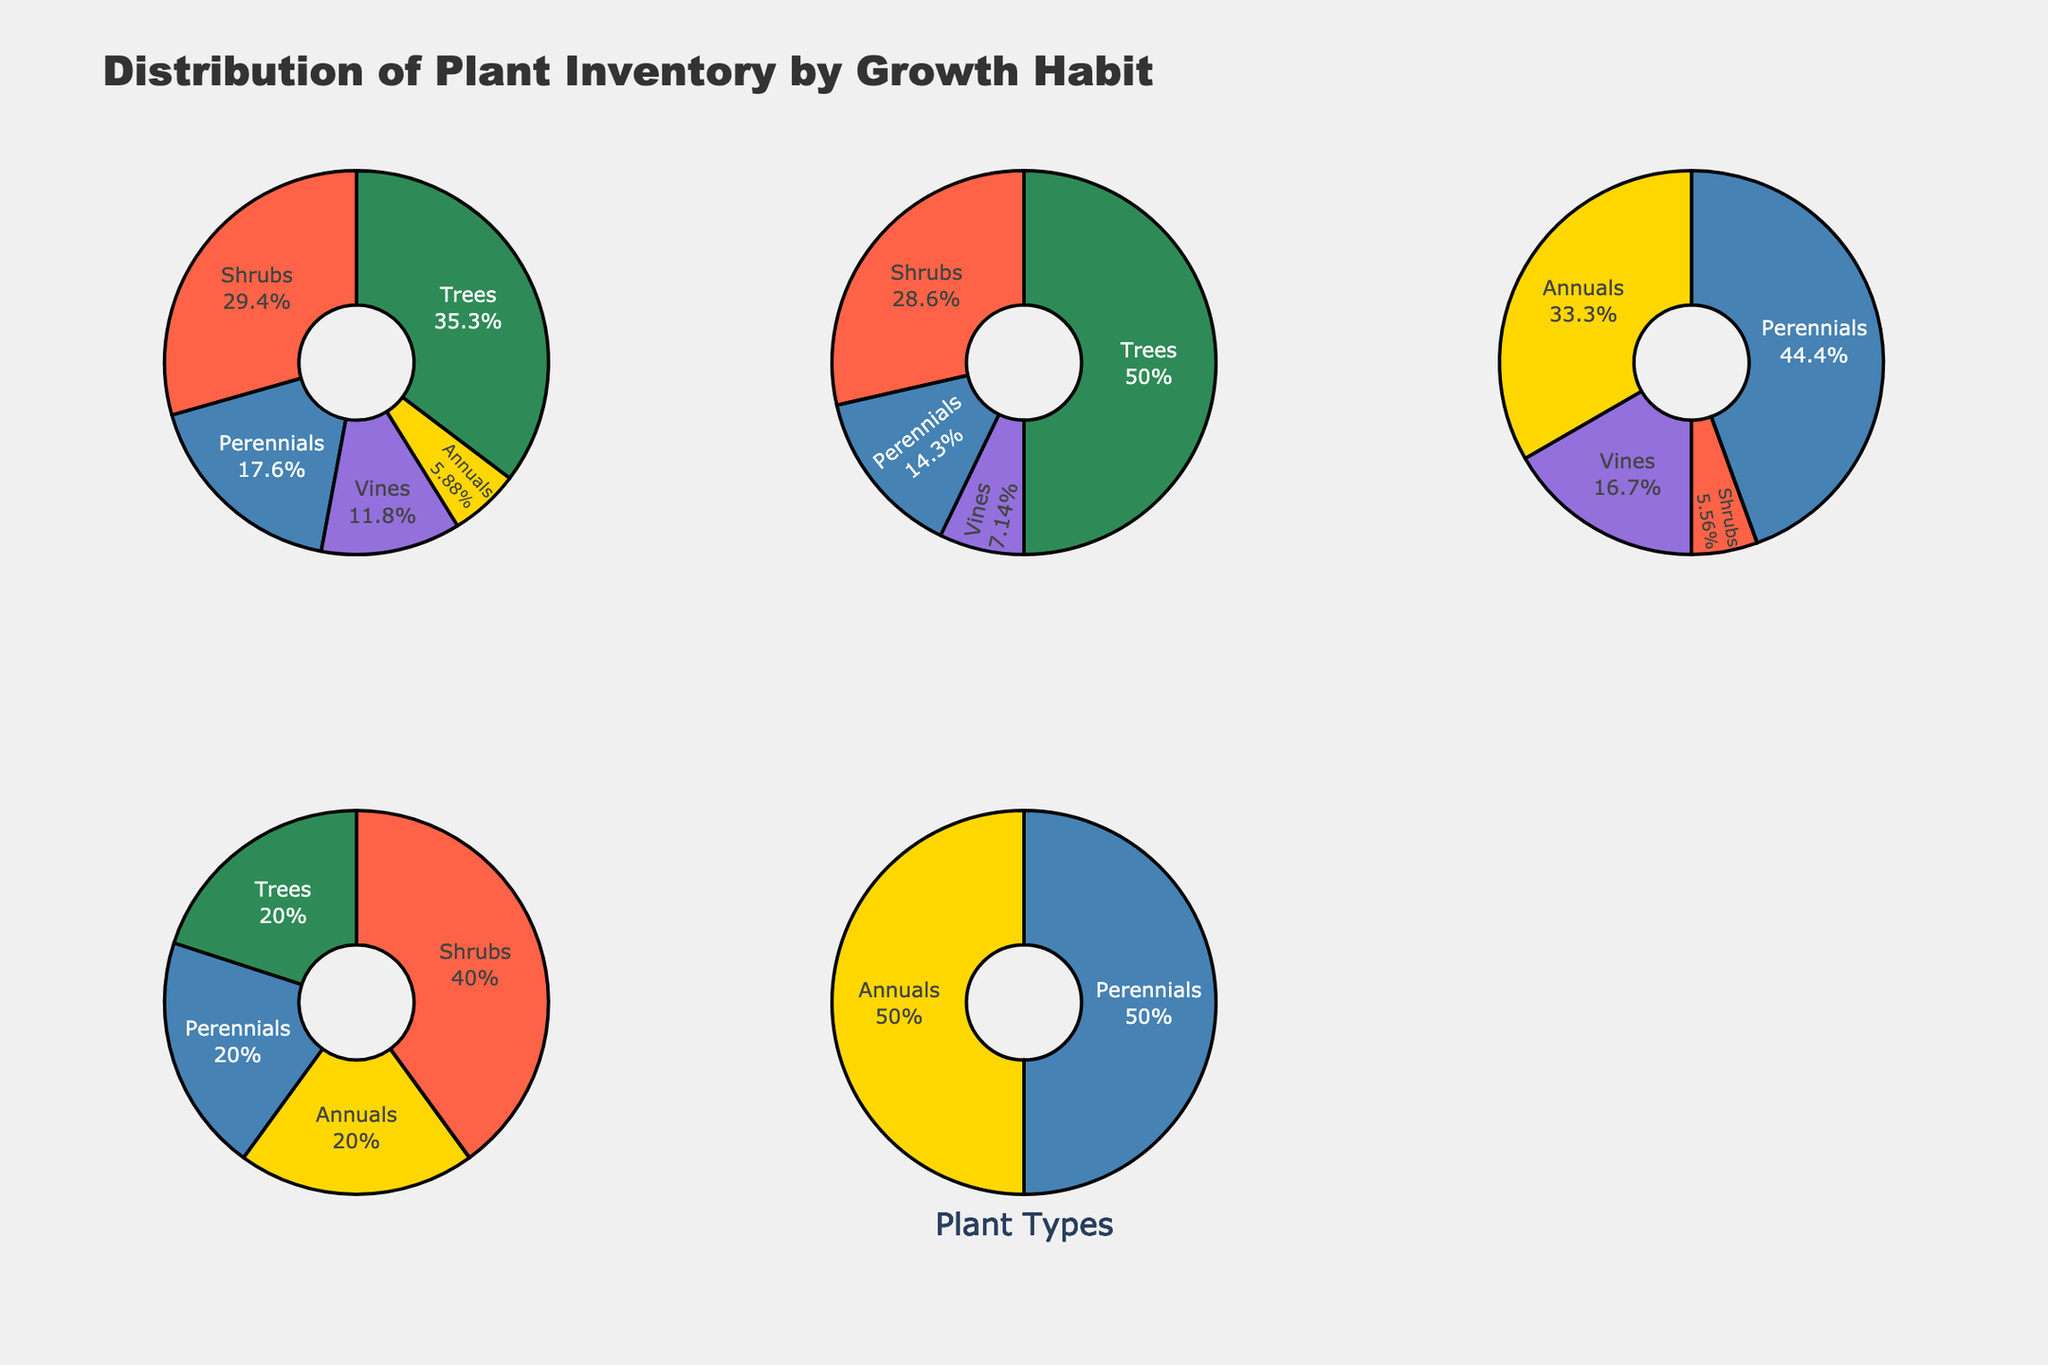how many growth habits are displayed in the figure? The figure shows pie charts for different growth habits. Counting the subplot titles, there are five growth habits displayed.
Answer: Five Which plant type has the highest percentage in the Herbaceous growth habit? The pie chart for Herbaceous shows the percentage distribution among different plant types. The one with the highest percentage is the most populated type. Herbaceous has a large section which represents Perennials.
Answer: Perennials Which growth habit has the smallest proportion of Annuals? Look at the pie sections labeled for Annuals in each growth habit. The smallest section will have the smallest proportion. Comparing all pie charts, Evergreen, Deciduous, Succulent, and Aquatic have smaller sections for Annuals, but Deciduous has a noticeably small or non-existent section.
Answer: Deciduous What is the combined number of Trees in Evergreen and Deciduous growth habits? Refer to the figures for Evergreen and Deciduous growth habits. Sum the number of Trees in each. Evergreen has 30 Trees, and Deciduous has 35 Trees. Combined, it is 30 + 35.
Answer: 65 Which growth habit does not include any Vines? Scan the pie charts for each growth habit to find the one that does not show a section for Vines. The Aquatic growth habit has no section for Vines.
Answer: Aquatic Which growth habit has the largest number of Vines? Compare the size of the Vines sections in each pie chart, noting their numerical values if visible. Herbaceous has the segment with the largest number.
Answer: Herbaceous For the growth habit Succulent, what is the ratio of Shrubs to Annuals? Looking at the pie chart for Succulent, identify the values for Shrubs and Annuals. Succulent has 10 Shrubs and 5 Annuals. The ratio is 10 to 5 which simplifies to 2:1.
Answer: 2:1 How do the proportions of Perennials in Evergreen and Deciduous compare? Examine the pie charts for Evergreen and Deciduous to compare their Perennials sections. Determine which is greater. Evergreen appears to have a larger section for Perennials, though both seem relatively close.
Answer: Evergreen has more Perennials In which growth habit do Trees make up the majority of the plant inventory? Check the pie charts for each growth habit and identify the largest section. Trees make up the majority in both Evergreen and Deciduous, but Deciduous has a larger majority for Trees.
Answer: Deciduous 